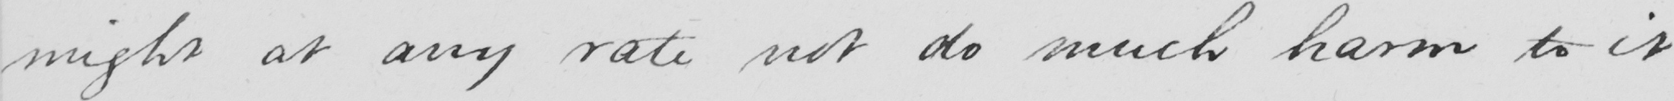Please transcribe the handwritten text in this image. might at any rate not do much harm to it 